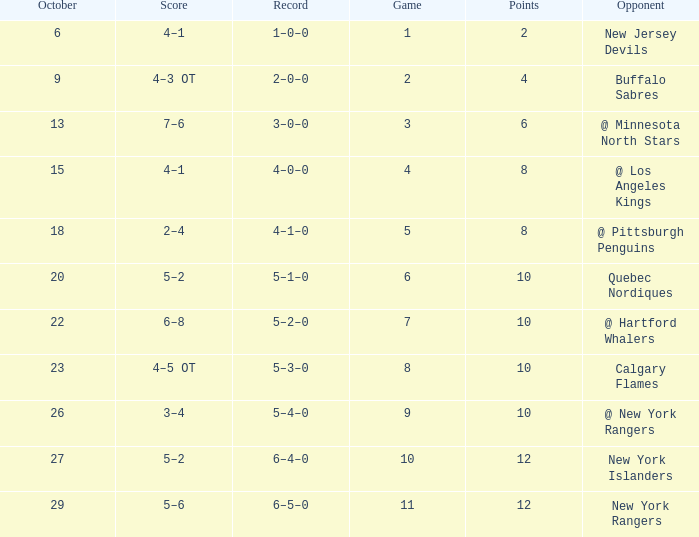Give me the full table as a dictionary. {'header': ['October', 'Score', 'Record', 'Game', 'Points', 'Opponent'], 'rows': [['6', '4–1', '1–0–0', '1', '2', 'New Jersey Devils'], ['9', '4–3 OT', '2–0–0', '2', '4', 'Buffalo Sabres'], ['13', '7–6', '3–0–0', '3', '6', '@ Minnesota North Stars'], ['15', '4–1', '4–0–0', '4', '8', '@ Los Angeles Kings'], ['18', '2–4', '4–1–0', '5', '8', '@ Pittsburgh Penguins'], ['20', '5–2', '5–1–0', '6', '10', 'Quebec Nordiques'], ['22', '6–8', '5–2–0', '7', '10', '@ Hartford Whalers'], ['23', '4–5 OT', '5–3–0', '8', '10', 'Calgary Flames'], ['26', '3–4', '5–4–0', '9', '10', '@ New York Rangers'], ['27', '5–2', '6–4–0', '10', '12', 'New York Islanders'], ['29', '5–6', '6–5–0', '11', '12', 'New York Rangers']]} How many Points have an Opponent of @ los angeles kings and a Game larger than 4? None. 